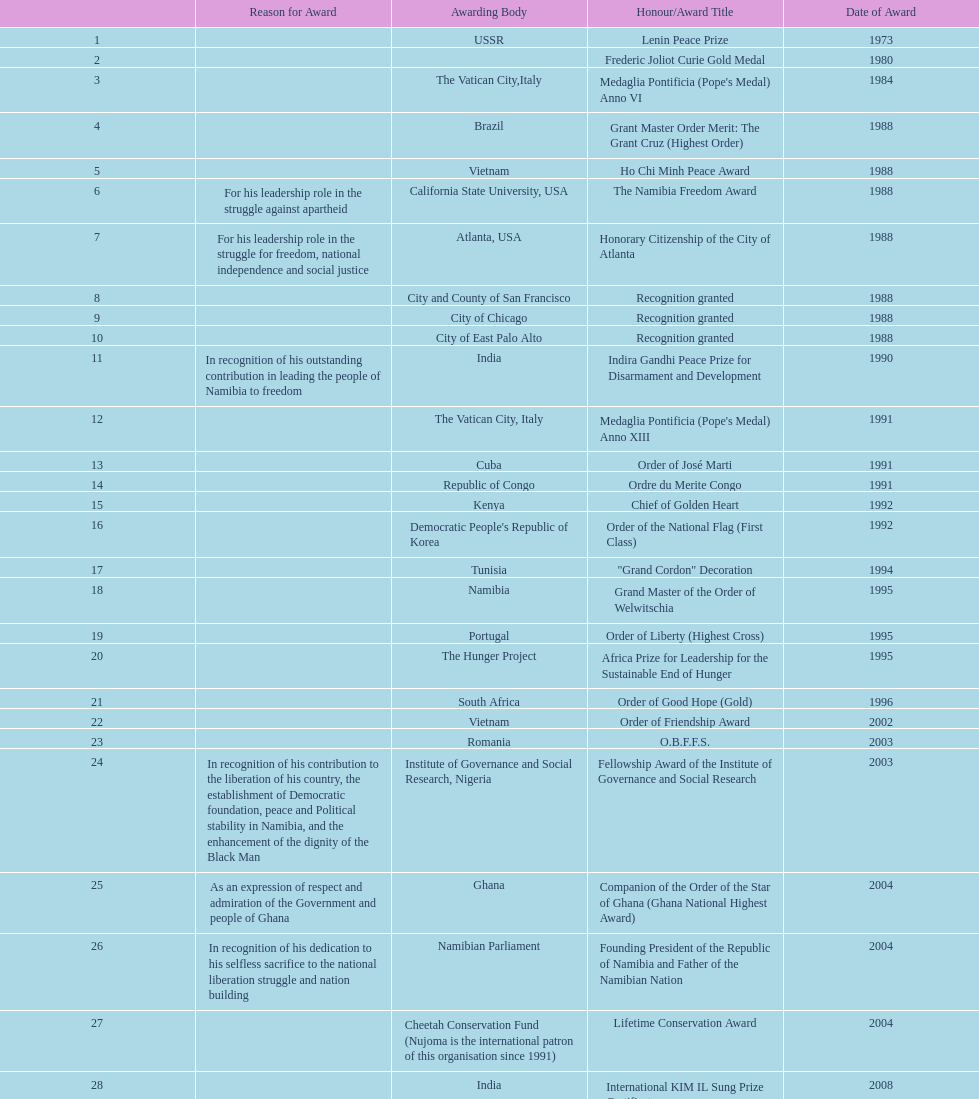What was the name of the honor/award title given after the international kim il sung prize certificate? Sir Seretse Khama SADC Meda. 